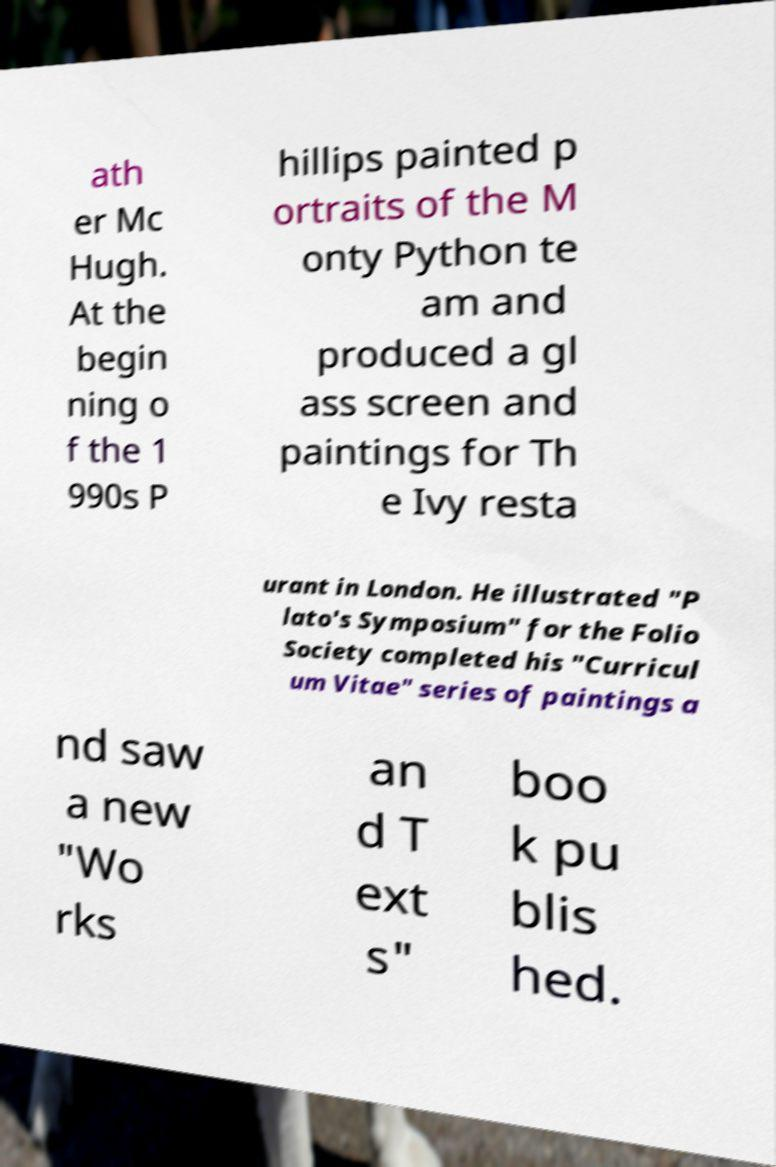Please identify and transcribe the text found in this image. ath er Mc Hugh. At the begin ning o f the 1 990s P hillips painted p ortraits of the M onty Python te am and produced a gl ass screen and paintings for Th e Ivy resta urant in London. He illustrated "P lato's Symposium" for the Folio Society completed his "Curricul um Vitae" series of paintings a nd saw a new "Wo rks an d T ext s" boo k pu blis hed. 